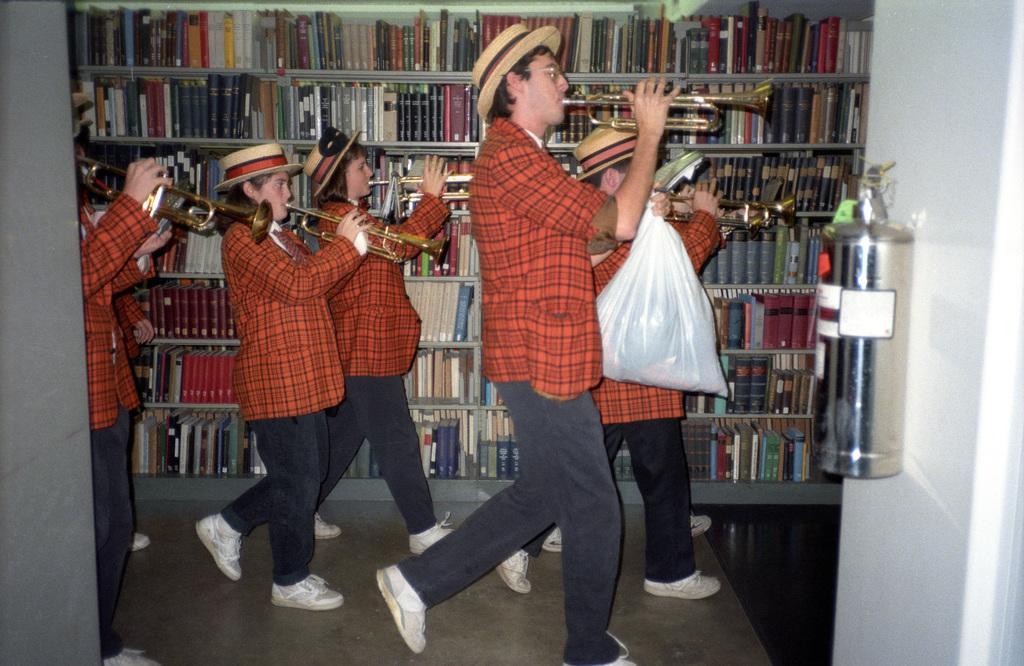Please provide a concise description of this image. In this image we can see people are walking by playing musical instrument, they are wearing red color jacket with jeans. Background of the image book rack is there. Right side of the image one silver color container is attached to the white color wall. 